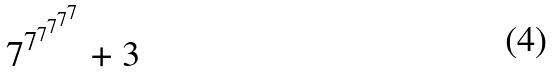Convert formula to latex. <formula><loc_0><loc_0><loc_500><loc_500>7 ^ { 7 ^ { 7 ^ { 7 ^ { 7 ^ { 7 } } } } } + 3</formula> 